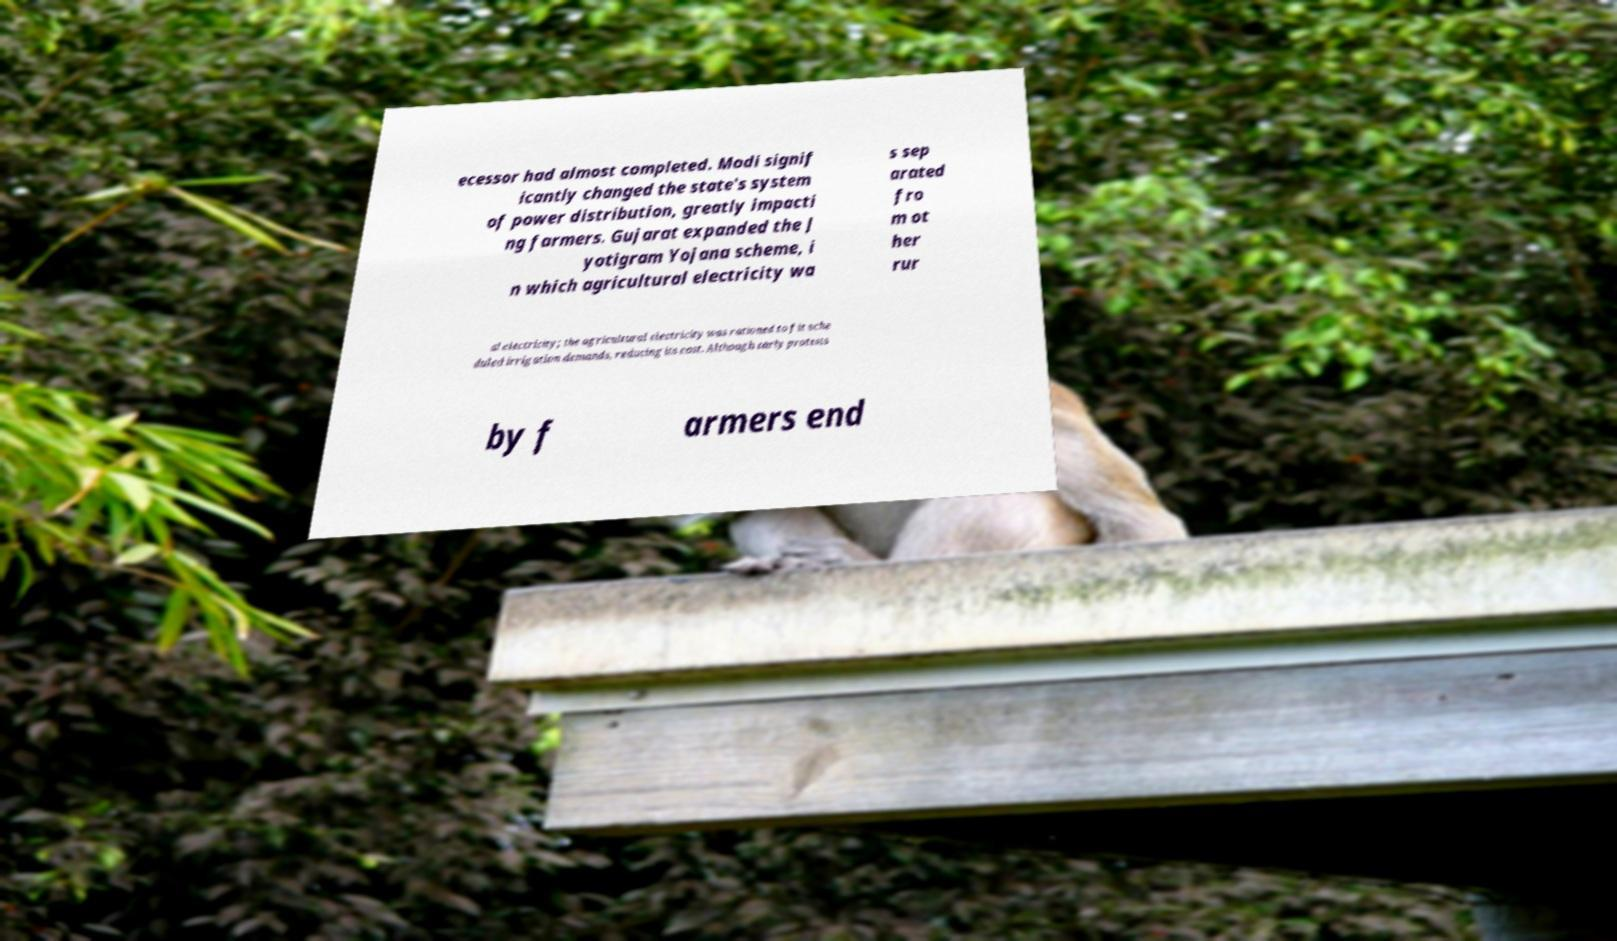What messages or text are displayed in this image? I need them in a readable, typed format. ecessor had almost completed. Modi signif icantly changed the state's system of power distribution, greatly impacti ng farmers. Gujarat expanded the J yotigram Yojana scheme, i n which agricultural electricity wa s sep arated fro m ot her rur al electricity; the agricultural electricity was rationed to fit sche duled irrigation demands, reducing its cost. Although early protests by f armers end 